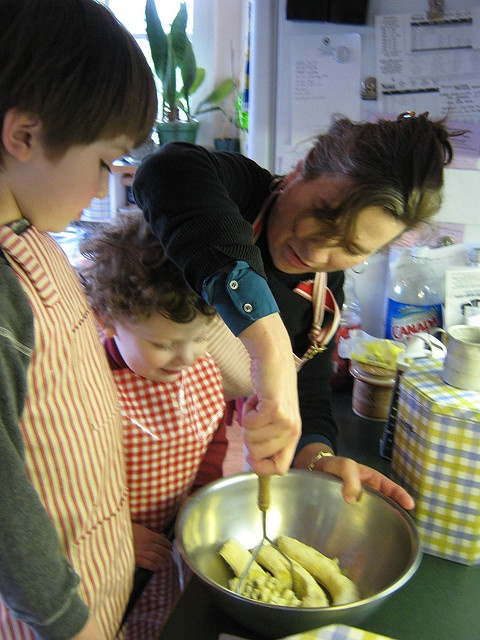Describe the objects in this image and their specific colors. I can see people in black, khaki, and gray tones, people in black, maroon, and tan tones, people in black, brown, maroon, and gray tones, bowl in black, gray, and olive tones, and banana in black, khaki, and olive tones in this image. 